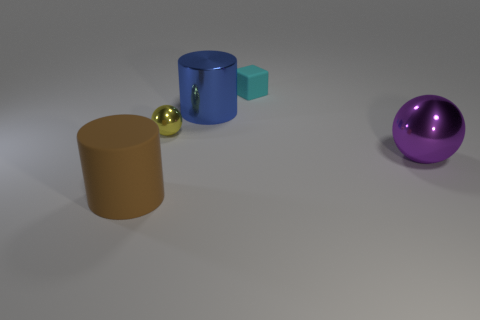What textures can be observed on the different objects in the image? In the image, the textures vary significantly among the objects. The brown cylinder and the small cyan object exhibit a matte finish suggesting a rubber-like material. The blue cylinder and the purple sphere have shiny, smooth surfaces indicative of metal, reflecting light vividly. 